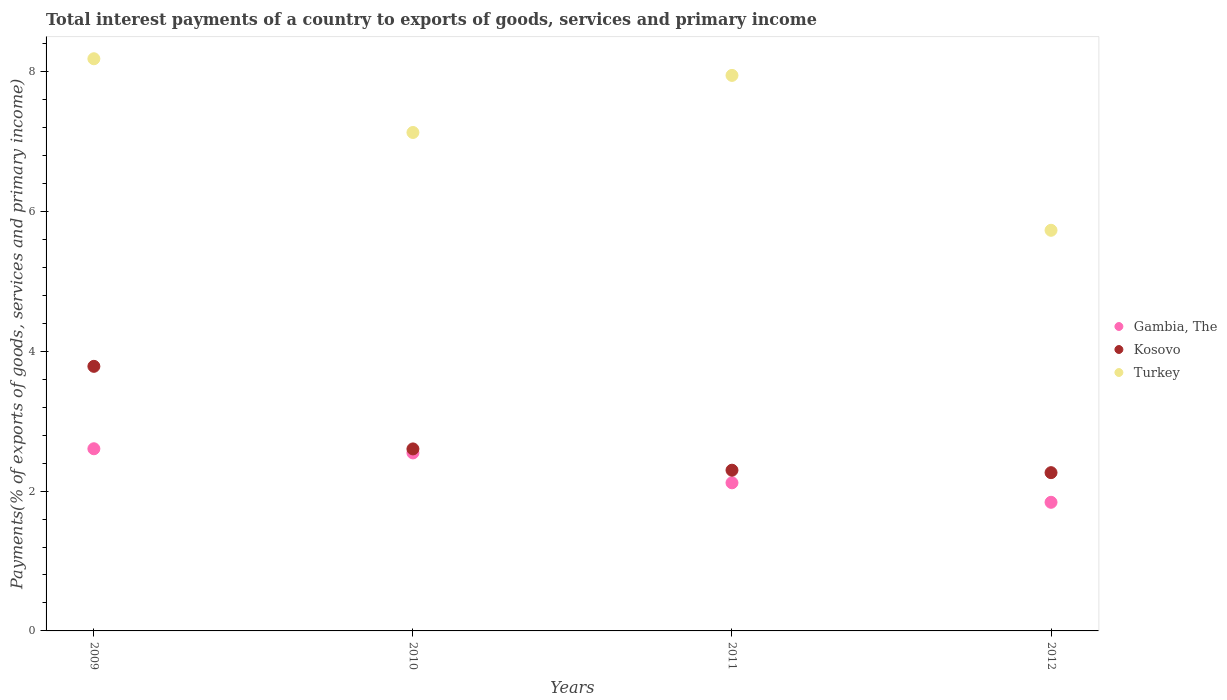How many different coloured dotlines are there?
Give a very brief answer. 3. What is the total interest payments in Turkey in 2012?
Keep it short and to the point. 5.73. Across all years, what is the maximum total interest payments in Gambia, The?
Your response must be concise. 2.61. Across all years, what is the minimum total interest payments in Gambia, The?
Offer a terse response. 1.84. What is the total total interest payments in Turkey in the graph?
Make the answer very short. 28.98. What is the difference between the total interest payments in Kosovo in 2010 and that in 2012?
Your answer should be very brief. 0.34. What is the difference between the total interest payments in Kosovo in 2011 and the total interest payments in Gambia, The in 2009?
Your answer should be very brief. -0.31. What is the average total interest payments in Gambia, The per year?
Offer a very short reply. 2.28. In the year 2011, what is the difference between the total interest payments in Kosovo and total interest payments in Turkey?
Your response must be concise. -5.65. What is the ratio of the total interest payments in Kosovo in 2009 to that in 2012?
Your answer should be very brief. 1.67. Is the difference between the total interest payments in Kosovo in 2010 and 2012 greater than the difference between the total interest payments in Turkey in 2010 and 2012?
Provide a succinct answer. No. What is the difference between the highest and the second highest total interest payments in Gambia, The?
Offer a very short reply. 0.06. What is the difference between the highest and the lowest total interest payments in Turkey?
Your answer should be very brief. 2.45. Is it the case that in every year, the sum of the total interest payments in Gambia, The and total interest payments in Turkey  is greater than the total interest payments in Kosovo?
Your answer should be compact. Yes. Is the total interest payments in Turkey strictly greater than the total interest payments in Gambia, The over the years?
Ensure brevity in your answer.  Yes. How many years are there in the graph?
Provide a succinct answer. 4. What is the difference between two consecutive major ticks on the Y-axis?
Your answer should be compact. 2. Are the values on the major ticks of Y-axis written in scientific E-notation?
Ensure brevity in your answer.  No. Does the graph contain grids?
Your response must be concise. No. What is the title of the graph?
Offer a very short reply. Total interest payments of a country to exports of goods, services and primary income. What is the label or title of the Y-axis?
Provide a succinct answer. Payments(% of exports of goods, services and primary income). What is the Payments(% of exports of goods, services and primary income) in Gambia, The in 2009?
Ensure brevity in your answer.  2.61. What is the Payments(% of exports of goods, services and primary income) of Kosovo in 2009?
Offer a terse response. 3.78. What is the Payments(% of exports of goods, services and primary income) in Turkey in 2009?
Offer a very short reply. 8.18. What is the Payments(% of exports of goods, services and primary income) in Gambia, The in 2010?
Make the answer very short. 2.55. What is the Payments(% of exports of goods, services and primary income) of Kosovo in 2010?
Make the answer very short. 2.6. What is the Payments(% of exports of goods, services and primary income) in Turkey in 2010?
Keep it short and to the point. 7.13. What is the Payments(% of exports of goods, services and primary income) in Gambia, The in 2011?
Provide a short and direct response. 2.12. What is the Payments(% of exports of goods, services and primary income) in Kosovo in 2011?
Your answer should be very brief. 2.3. What is the Payments(% of exports of goods, services and primary income) in Turkey in 2011?
Give a very brief answer. 7.94. What is the Payments(% of exports of goods, services and primary income) in Gambia, The in 2012?
Ensure brevity in your answer.  1.84. What is the Payments(% of exports of goods, services and primary income) in Kosovo in 2012?
Give a very brief answer. 2.26. What is the Payments(% of exports of goods, services and primary income) in Turkey in 2012?
Make the answer very short. 5.73. Across all years, what is the maximum Payments(% of exports of goods, services and primary income) in Gambia, The?
Your answer should be compact. 2.61. Across all years, what is the maximum Payments(% of exports of goods, services and primary income) in Kosovo?
Make the answer very short. 3.78. Across all years, what is the maximum Payments(% of exports of goods, services and primary income) of Turkey?
Offer a terse response. 8.18. Across all years, what is the minimum Payments(% of exports of goods, services and primary income) of Gambia, The?
Offer a very short reply. 1.84. Across all years, what is the minimum Payments(% of exports of goods, services and primary income) of Kosovo?
Offer a very short reply. 2.26. Across all years, what is the minimum Payments(% of exports of goods, services and primary income) in Turkey?
Your answer should be compact. 5.73. What is the total Payments(% of exports of goods, services and primary income) of Gambia, The in the graph?
Provide a short and direct response. 9.11. What is the total Payments(% of exports of goods, services and primary income) in Kosovo in the graph?
Your response must be concise. 10.95. What is the total Payments(% of exports of goods, services and primary income) in Turkey in the graph?
Provide a short and direct response. 28.98. What is the difference between the Payments(% of exports of goods, services and primary income) in Gambia, The in 2009 and that in 2010?
Make the answer very short. 0.06. What is the difference between the Payments(% of exports of goods, services and primary income) in Kosovo in 2009 and that in 2010?
Provide a succinct answer. 1.18. What is the difference between the Payments(% of exports of goods, services and primary income) of Turkey in 2009 and that in 2010?
Keep it short and to the point. 1.05. What is the difference between the Payments(% of exports of goods, services and primary income) in Gambia, The in 2009 and that in 2011?
Make the answer very short. 0.49. What is the difference between the Payments(% of exports of goods, services and primary income) of Kosovo in 2009 and that in 2011?
Offer a very short reply. 1.49. What is the difference between the Payments(% of exports of goods, services and primary income) of Turkey in 2009 and that in 2011?
Your answer should be very brief. 0.24. What is the difference between the Payments(% of exports of goods, services and primary income) of Gambia, The in 2009 and that in 2012?
Ensure brevity in your answer.  0.77. What is the difference between the Payments(% of exports of goods, services and primary income) in Kosovo in 2009 and that in 2012?
Give a very brief answer. 1.52. What is the difference between the Payments(% of exports of goods, services and primary income) in Turkey in 2009 and that in 2012?
Your response must be concise. 2.45. What is the difference between the Payments(% of exports of goods, services and primary income) of Gambia, The in 2010 and that in 2011?
Give a very brief answer. 0.43. What is the difference between the Payments(% of exports of goods, services and primary income) in Kosovo in 2010 and that in 2011?
Your response must be concise. 0.3. What is the difference between the Payments(% of exports of goods, services and primary income) in Turkey in 2010 and that in 2011?
Provide a short and direct response. -0.82. What is the difference between the Payments(% of exports of goods, services and primary income) of Gambia, The in 2010 and that in 2012?
Provide a succinct answer. 0.71. What is the difference between the Payments(% of exports of goods, services and primary income) in Kosovo in 2010 and that in 2012?
Offer a terse response. 0.34. What is the difference between the Payments(% of exports of goods, services and primary income) in Turkey in 2010 and that in 2012?
Your response must be concise. 1.4. What is the difference between the Payments(% of exports of goods, services and primary income) of Gambia, The in 2011 and that in 2012?
Offer a terse response. 0.28. What is the difference between the Payments(% of exports of goods, services and primary income) of Kosovo in 2011 and that in 2012?
Your answer should be very brief. 0.04. What is the difference between the Payments(% of exports of goods, services and primary income) in Turkey in 2011 and that in 2012?
Provide a short and direct response. 2.22. What is the difference between the Payments(% of exports of goods, services and primary income) in Gambia, The in 2009 and the Payments(% of exports of goods, services and primary income) in Kosovo in 2010?
Offer a very short reply. 0. What is the difference between the Payments(% of exports of goods, services and primary income) of Gambia, The in 2009 and the Payments(% of exports of goods, services and primary income) of Turkey in 2010?
Your answer should be very brief. -4.52. What is the difference between the Payments(% of exports of goods, services and primary income) in Kosovo in 2009 and the Payments(% of exports of goods, services and primary income) in Turkey in 2010?
Provide a short and direct response. -3.34. What is the difference between the Payments(% of exports of goods, services and primary income) of Gambia, The in 2009 and the Payments(% of exports of goods, services and primary income) of Kosovo in 2011?
Provide a succinct answer. 0.31. What is the difference between the Payments(% of exports of goods, services and primary income) in Gambia, The in 2009 and the Payments(% of exports of goods, services and primary income) in Turkey in 2011?
Your answer should be compact. -5.34. What is the difference between the Payments(% of exports of goods, services and primary income) in Kosovo in 2009 and the Payments(% of exports of goods, services and primary income) in Turkey in 2011?
Your response must be concise. -4.16. What is the difference between the Payments(% of exports of goods, services and primary income) in Gambia, The in 2009 and the Payments(% of exports of goods, services and primary income) in Kosovo in 2012?
Ensure brevity in your answer.  0.34. What is the difference between the Payments(% of exports of goods, services and primary income) in Gambia, The in 2009 and the Payments(% of exports of goods, services and primary income) in Turkey in 2012?
Provide a succinct answer. -3.12. What is the difference between the Payments(% of exports of goods, services and primary income) in Kosovo in 2009 and the Payments(% of exports of goods, services and primary income) in Turkey in 2012?
Offer a terse response. -1.95. What is the difference between the Payments(% of exports of goods, services and primary income) of Gambia, The in 2010 and the Payments(% of exports of goods, services and primary income) of Kosovo in 2011?
Give a very brief answer. 0.25. What is the difference between the Payments(% of exports of goods, services and primary income) in Gambia, The in 2010 and the Payments(% of exports of goods, services and primary income) in Turkey in 2011?
Your answer should be very brief. -5.4. What is the difference between the Payments(% of exports of goods, services and primary income) of Kosovo in 2010 and the Payments(% of exports of goods, services and primary income) of Turkey in 2011?
Your answer should be compact. -5.34. What is the difference between the Payments(% of exports of goods, services and primary income) in Gambia, The in 2010 and the Payments(% of exports of goods, services and primary income) in Kosovo in 2012?
Your response must be concise. 0.28. What is the difference between the Payments(% of exports of goods, services and primary income) of Gambia, The in 2010 and the Payments(% of exports of goods, services and primary income) of Turkey in 2012?
Your response must be concise. -3.18. What is the difference between the Payments(% of exports of goods, services and primary income) of Kosovo in 2010 and the Payments(% of exports of goods, services and primary income) of Turkey in 2012?
Keep it short and to the point. -3.13. What is the difference between the Payments(% of exports of goods, services and primary income) in Gambia, The in 2011 and the Payments(% of exports of goods, services and primary income) in Kosovo in 2012?
Offer a terse response. -0.15. What is the difference between the Payments(% of exports of goods, services and primary income) in Gambia, The in 2011 and the Payments(% of exports of goods, services and primary income) in Turkey in 2012?
Your answer should be very brief. -3.61. What is the difference between the Payments(% of exports of goods, services and primary income) in Kosovo in 2011 and the Payments(% of exports of goods, services and primary income) in Turkey in 2012?
Provide a short and direct response. -3.43. What is the average Payments(% of exports of goods, services and primary income) in Gambia, The per year?
Keep it short and to the point. 2.28. What is the average Payments(% of exports of goods, services and primary income) in Kosovo per year?
Your response must be concise. 2.74. What is the average Payments(% of exports of goods, services and primary income) in Turkey per year?
Make the answer very short. 7.25. In the year 2009, what is the difference between the Payments(% of exports of goods, services and primary income) in Gambia, The and Payments(% of exports of goods, services and primary income) in Kosovo?
Offer a terse response. -1.18. In the year 2009, what is the difference between the Payments(% of exports of goods, services and primary income) in Gambia, The and Payments(% of exports of goods, services and primary income) in Turkey?
Your answer should be compact. -5.58. In the year 2009, what is the difference between the Payments(% of exports of goods, services and primary income) in Kosovo and Payments(% of exports of goods, services and primary income) in Turkey?
Make the answer very short. -4.4. In the year 2010, what is the difference between the Payments(% of exports of goods, services and primary income) of Gambia, The and Payments(% of exports of goods, services and primary income) of Kosovo?
Your answer should be very brief. -0.06. In the year 2010, what is the difference between the Payments(% of exports of goods, services and primary income) of Gambia, The and Payments(% of exports of goods, services and primary income) of Turkey?
Your answer should be very brief. -4.58. In the year 2010, what is the difference between the Payments(% of exports of goods, services and primary income) of Kosovo and Payments(% of exports of goods, services and primary income) of Turkey?
Your response must be concise. -4.53. In the year 2011, what is the difference between the Payments(% of exports of goods, services and primary income) in Gambia, The and Payments(% of exports of goods, services and primary income) in Kosovo?
Offer a very short reply. -0.18. In the year 2011, what is the difference between the Payments(% of exports of goods, services and primary income) in Gambia, The and Payments(% of exports of goods, services and primary income) in Turkey?
Ensure brevity in your answer.  -5.83. In the year 2011, what is the difference between the Payments(% of exports of goods, services and primary income) in Kosovo and Payments(% of exports of goods, services and primary income) in Turkey?
Give a very brief answer. -5.65. In the year 2012, what is the difference between the Payments(% of exports of goods, services and primary income) in Gambia, The and Payments(% of exports of goods, services and primary income) in Kosovo?
Provide a succinct answer. -0.42. In the year 2012, what is the difference between the Payments(% of exports of goods, services and primary income) in Gambia, The and Payments(% of exports of goods, services and primary income) in Turkey?
Provide a short and direct response. -3.89. In the year 2012, what is the difference between the Payments(% of exports of goods, services and primary income) of Kosovo and Payments(% of exports of goods, services and primary income) of Turkey?
Make the answer very short. -3.47. What is the ratio of the Payments(% of exports of goods, services and primary income) of Gambia, The in 2009 to that in 2010?
Keep it short and to the point. 1.02. What is the ratio of the Payments(% of exports of goods, services and primary income) of Kosovo in 2009 to that in 2010?
Give a very brief answer. 1.45. What is the ratio of the Payments(% of exports of goods, services and primary income) in Turkey in 2009 to that in 2010?
Give a very brief answer. 1.15. What is the ratio of the Payments(% of exports of goods, services and primary income) in Gambia, The in 2009 to that in 2011?
Keep it short and to the point. 1.23. What is the ratio of the Payments(% of exports of goods, services and primary income) of Kosovo in 2009 to that in 2011?
Offer a terse response. 1.65. What is the ratio of the Payments(% of exports of goods, services and primary income) of Gambia, The in 2009 to that in 2012?
Give a very brief answer. 1.42. What is the ratio of the Payments(% of exports of goods, services and primary income) of Kosovo in 2009 to that in 2012?
Your answer should be very brief. 1.67. What is the ratio of the Payments(% of exports of goods, services and primary income) in Turkey in 2009 to that in 2012?
Give a very brief answer. 1.43. What is the ratio of the Payments(% of exports of goods, services and primary income) in Gambia, The in 2010 to that in 2011?
Your answer should be compact. 1.2. What is the ratio of the Payments(% of exports of goods, services and primary income) in Kosovo in 2010 to that in 2011?
Your answer should be compact. 1.13. What is the ratio of the Payments(% of exports of goods, services and primary income) in Turkey in 2010 to that in 2011?
Keep it short and to the point. 0.9. What is the ratio of the Payments(% of exports of goods, services and primary income) of Gambia, The in 2010 to that in 2012?
Ensure brevity in your answer.  1.38. What is the ratio of the Payments(% of exports of goods, services and primary income) in Kosovo in 2010 to that in 2012?
Make the answer very short. 1.15. What is the ratio of the Payments(% of exports of goods, services and primary income) in Turkey in 2010 to that in 2012?
Keep it short and to the point. 1.24. What is the ratio of the Payments(% of exports of goods, services and primary income) in Gambia, The in 2011 to that in 2012?
Your answer should be very brief. 1.15. What is the ratio of the Payments(% of exports of goods, services and primary income) in Kosovo in 2011 to that in 2012?
Your answer should be very brief. 1.02. What is the ratio of the Payments(% of exports of goods, services and primary income) of Turkey in 2011 to that in 2012?
Your answer should be very brief. 1.39. What is the difference between the highest and the second highest Payments(% of exports of goods, services and primary income) in Gambia, The?
Ensure brevity in your answer.  0.06. What is the difference between the highest and the second highest Payments(% of exports of goods, services and primary income) of Kosovo?
Your answer should be very brief. 1.18. What is the difference between the highest and the second highest Payments(% of exports of goods, services and primary income) in Turkey?
Ensure brevity in your answer.  0.24. What is the difference between the highest and the lowest Payments(% of exports of goods, services and primary income) in Gambia, The?
Provide a short and direct response. 0.77. What is the difference between the highest and the lowest Payments(% of exports of goods, services and primary income) of Kosovo?
Provide a succinct answer. 1.52. What is the difference between the highest and the lowest Payments(% of exports of goods, services and primary income) in Turkey?
Your answer should be very brief. 2.45. 